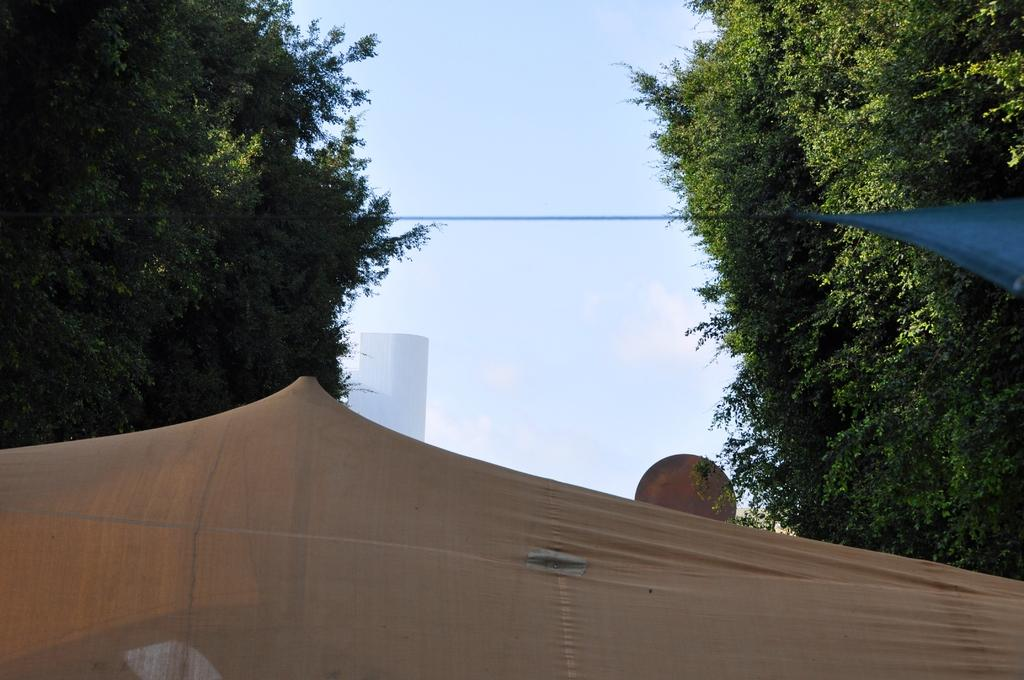What can be seen in the sky in the image? There is a sky visible in the image, but no specific details about the sky are provided. What type of vegetation is present in the image? There are trees in the image. What type of temporary shelter can be seen in the image? There are tents in the image. Can you describe the unspecified object in the image? Unfortunately, there is not enough information provided to describe the unspecified object in the image. How many girls are visible in the image? There is no mention of girls in the image, so it is impossible to determine their presence or number. What type of ticket can be seen in the image? There is no ticket present in the image. What is the cook doing in the image? There is no cook present in the image. 